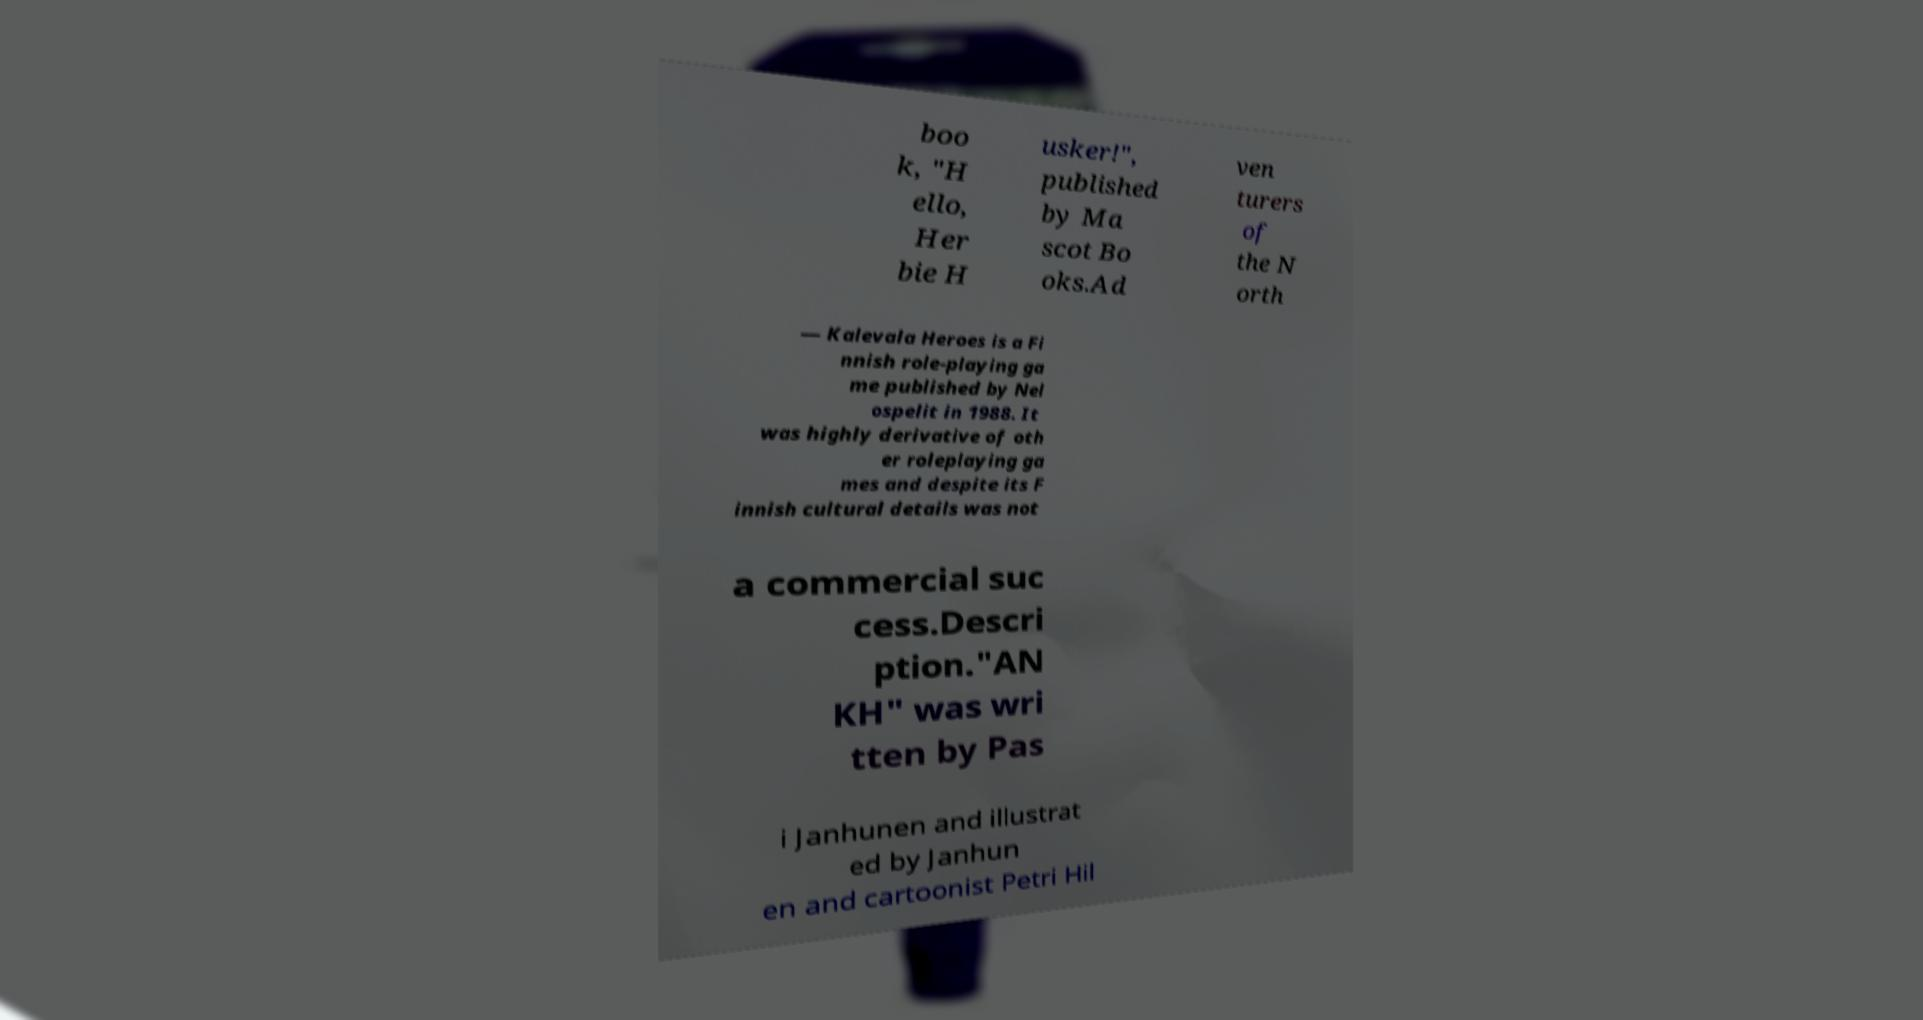There's text embedded in this image that I need extracted. Can you transcribe it verbatim? boo k, "H ello, Her bie H usker!", published by Ma scot Bo oks.Ad ven turers of the N orth — Kalevala Heroes is a Fi nnish role-playing ga me published by Nel ospelit in 1988. It was highly derivative of oth er roleplaying ga mes and despite its F innish cultural details was not a commercial suc cess.Descri ption."AN KH" was wri tten by Pas i Janhunen and illustrat ed by Janhun en and cartoonist Petri Hil 